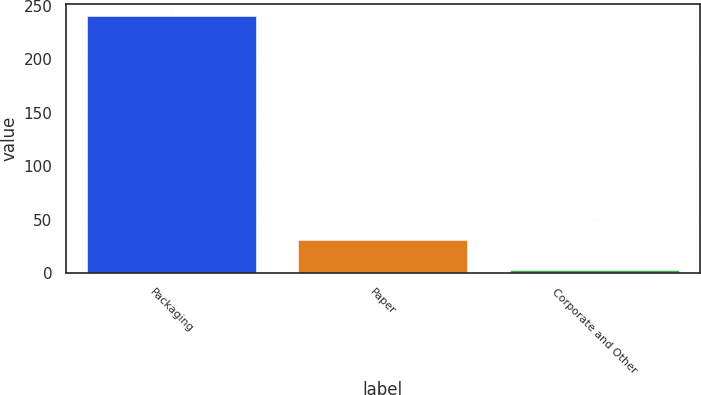Convert chart to OTSL. <chart><loc_0><loc_0><loc_500><loc_500><bar_chart><fcel>Packaging<fcel>Paper<fcel>Corporate and Other<nl><fcel>239.9<fcel>31.6<fcel>2.8<nl></chart> 